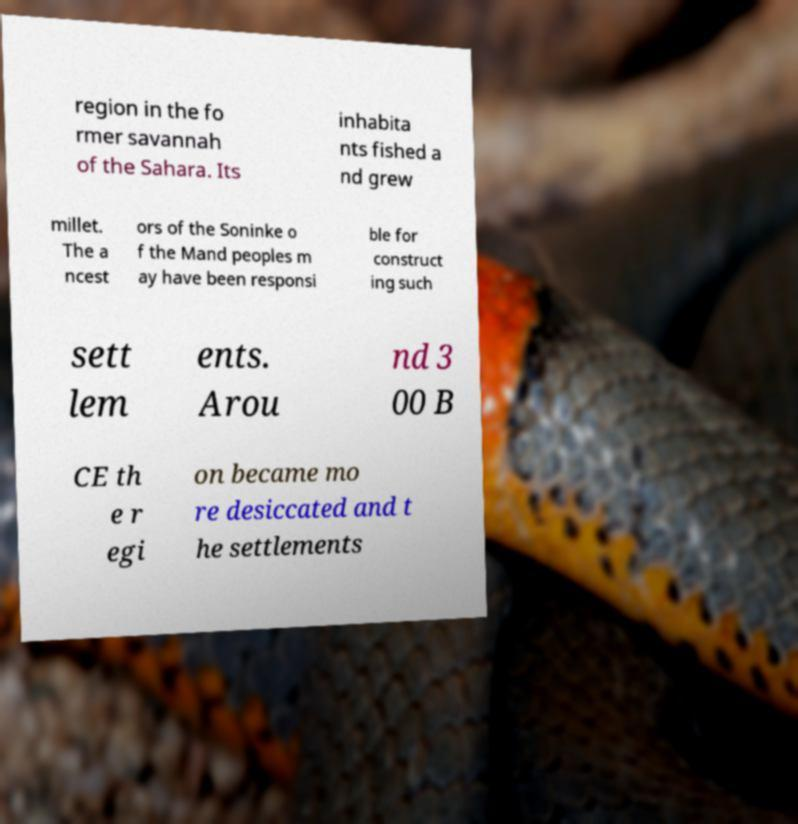There's text embedded in this image that I need extracted. Can you transcribe it verbatim? region in the fo rmer savannah of the Sahara. Its inhabita nts fished a nd grew millet. The a ncest ors of the Soninke o f the Mand peoples m ay have been responsi ble for construct ing such sett lem ents. Arou nd 3 00 B CE th e r egi on became mo re desiccated and t he settlements 